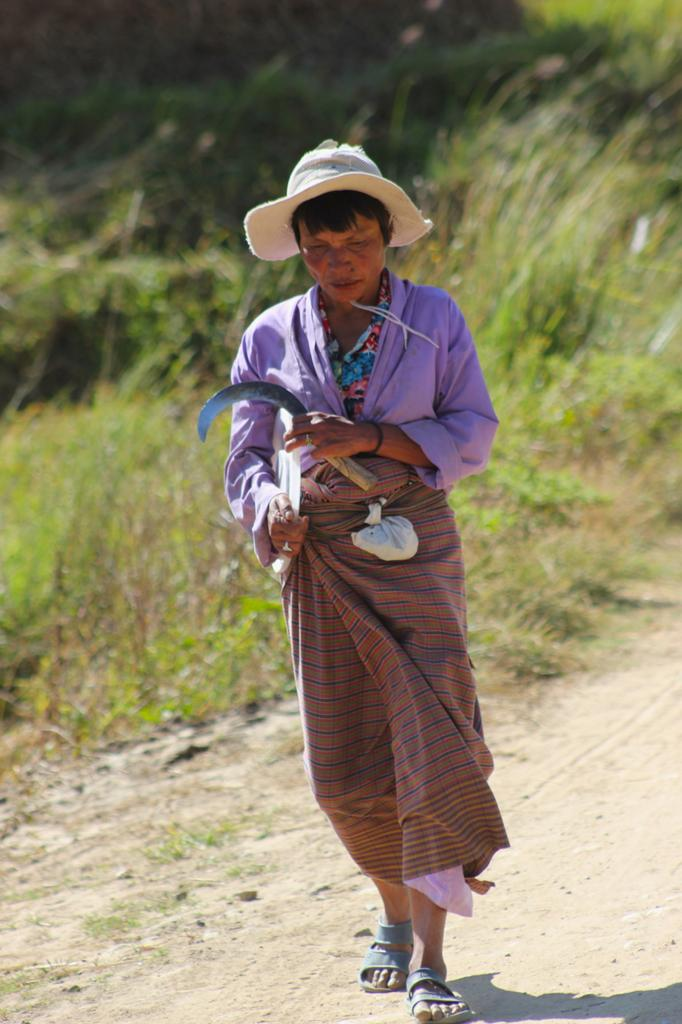What is the main subject of the image? There is a man standing in the image. What can be seen in the background of the image? There are plants and grass in the background of the image. What type of quill is the man using to write in the image? There is no quill present in the image, and the man is not writing. 